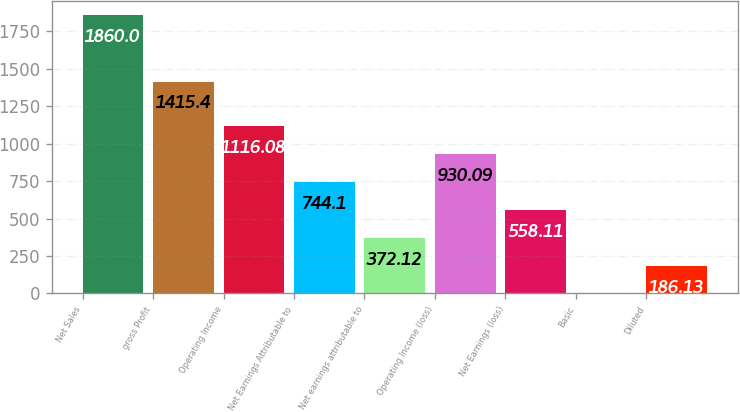Convert chart. <chart><loc_0><loc_0><loc_500><loc_500><bar_chart><fcel>Net Sales<fcel>gross Profit<fcel>Operating Income<fcel>Net Earnings Attributable to<fcel>Net earnings attributable to<fcel>Operating Income (loss)<fcel>Net Earnings (loss)<fcel>Basic<fcel>Diluted<nl><fcel>1860<fcel>1415.4<fcel>1116.08<fcel>744.1<fcel>372.12<fcel>930.09<fcel>558.11<fcel>0.14<fcel>186.13<nl></chart> 